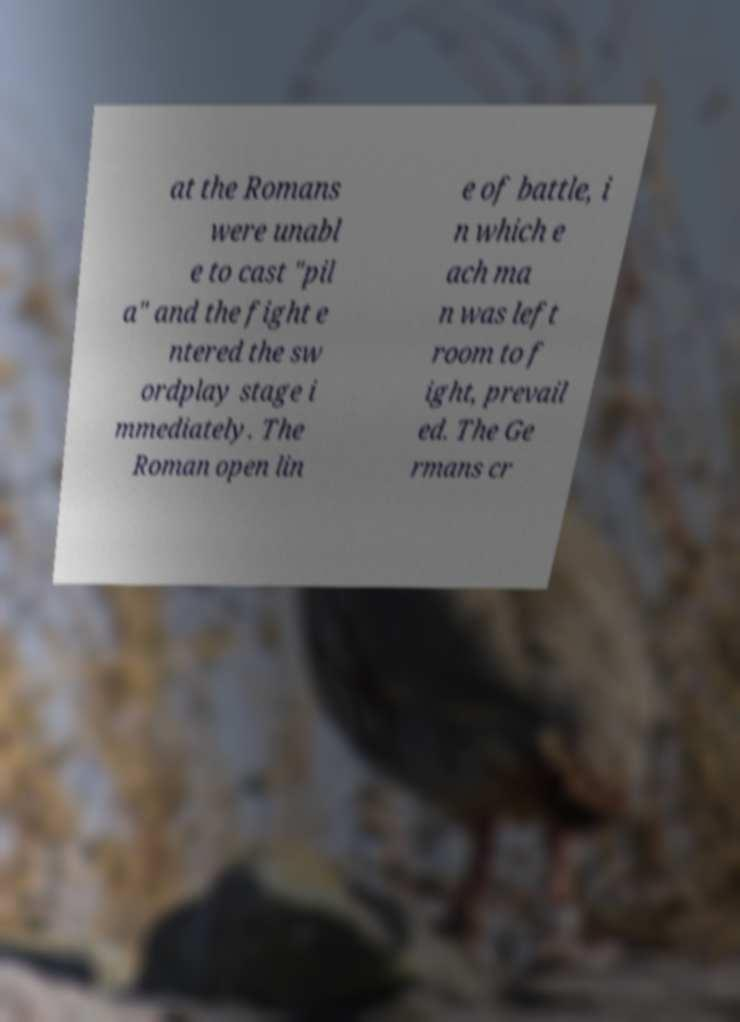Please identify and transcribe the text found in this image. at the Romans were unabl e to cast "pil a" and the fight e ntered the sw ordplay stage i mmediately. The Roman open lin e of battle, i n which e ach ma n was left room to f ight, prevail ed. The Ge rmans cr 